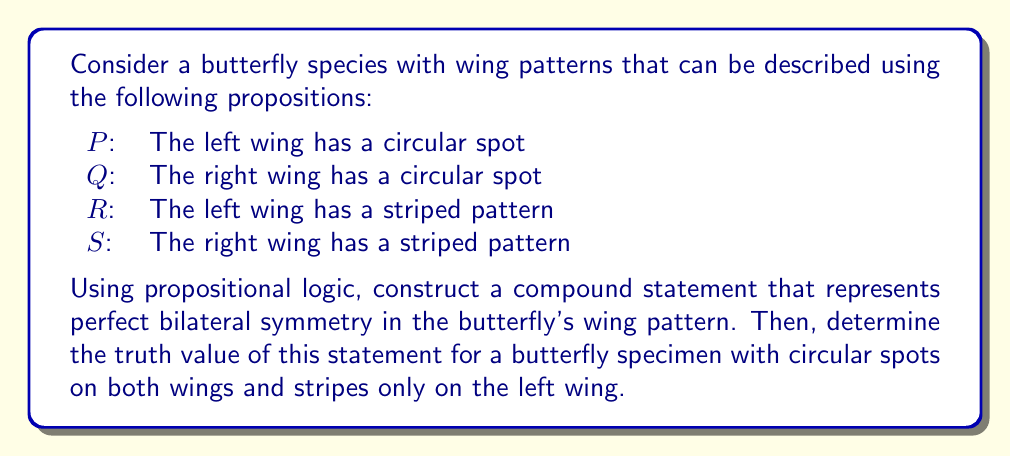Can you solve this math problem? To solve this problem, we'll follow these steps:

1. Construct a compound statement for perfect bilateral symmetry:
   Perfect bilateral symmetry means that whatever pattern exists on one wing must also exist on the other wing. We can express this using the biconditional operator (↔) for each pair of corresponding propositions:

   $$(P \leftrightarrow Q) \land (R \leftrightarrow S)$$

   This statement reads: "The left wing has a circular spot if and only if the right wing has a circular spot, AND the left wing has a striped pattern if and only if the right wing has a striped pattern."

2. Analyze the given butterfly specimen:
   - Both wings have circular spots: P is true, Q is true
   - Only the left wing has stripes: R is true, S is false

3. Evaluate the truth value of each part of the compound statement:
   a) $(P \leftrightarrow Q)$:
      Both P and Q are true, so $(P \leftrightarrow Q)$ is true.
   
   b) $(R \leftrightarrow S)$:
      R is true and S is false, so $(R \leftrightarrow S)$ is false.

4. Combine the results using the AND operator:
   $$(P \leftrightarrow Q) \land (R \leftrightarrow S)$$
   $$\text{True} \land \text{False} = \text{False}$$

Therefore, the compound statement representing perfect bilateral symmetry is false for this butterfly specimen.
Answer: False 